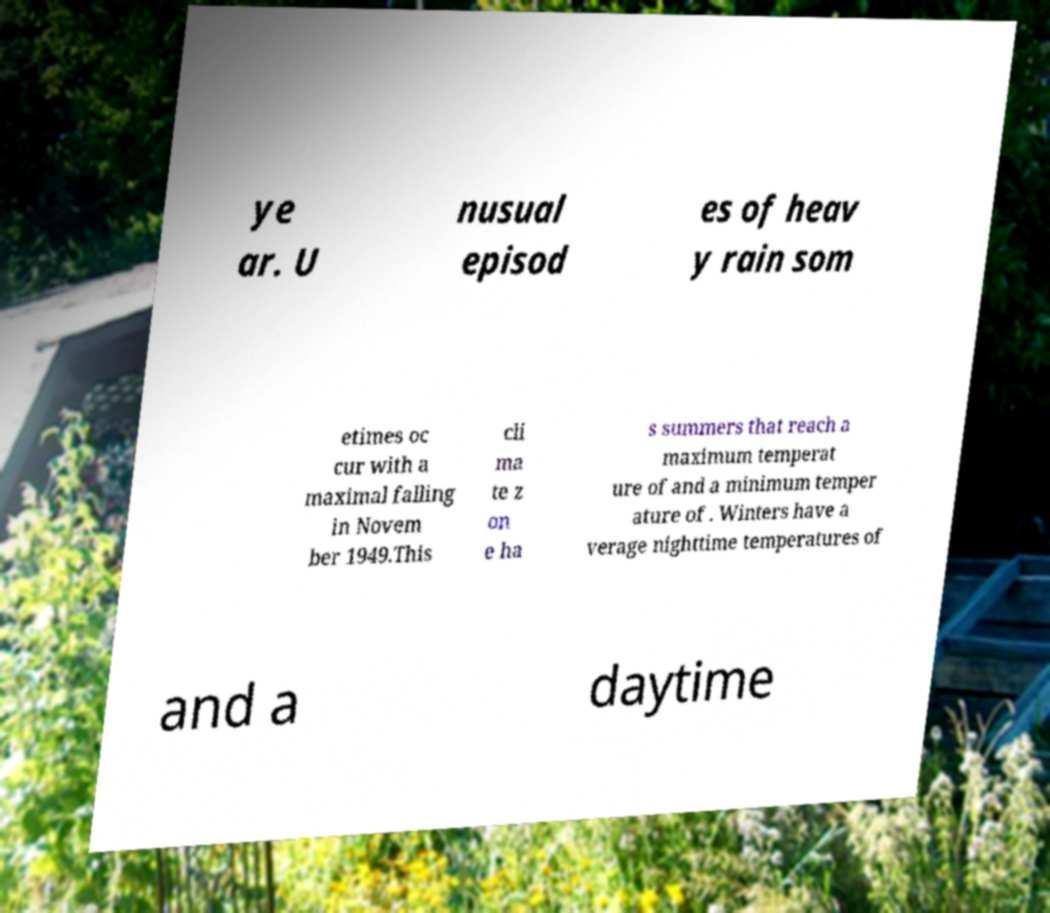What messages or text are displayed in this image? I need them in a readable, typed format. ye ar. U nusual episod es of heav y rain som etimes oc cur with a maximal falling in Novem ber 1949.This cli ma te z on e ha s summers that reach a maximum temperat ure of and a minimum temper ature of . Winters have a verage nighttime temperatures of and a daytime 